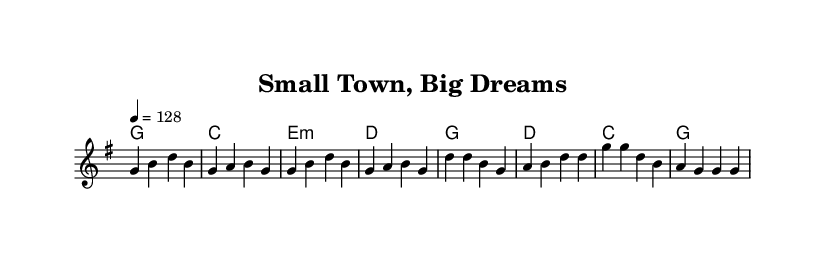What is the key signature of this music? The key signature is G major, indicated by one sharp (F#) which is visible in the sheet music’s key signature at the beginning.
Answer: G major What is the time signature of this music? The time signature is 4/4, which is shown at the beginning of the sheet music, indicating four beats per measure.
Answer: 4/4 What is the tempo marking for this piece? The tempo marking is 128 beats per minute, described in the tempo indication which is noted in the global section of the score.
Answer: 128 How many measures are in the verse? The verse consists of four measures, which can be counted from the melodic line where each measure has distinct rhythms and rests.
Answer: 4 What type of chords are used in the harmony for the verse? The harmony for the verse includes major and minor chords, specifically G major, C major, E minor, and D major as noted in the chord progression.
Answer: Major and minor What is the main theme of the lyrics in the chorus? The main theme of the chorus emphasizes hard work and traditional values, which reflect pride in one's small town and aspirations for the future stated in the lyrics.
Answer: Hard work and pride How does the melody of the chorus compare to the verse? The melody of the chorus features a higher pitch at the start (D note) and has a more uplifting phrasing, contrasting with the more stable and grounded lines in the verse.
Answer: Uplifting and higher pitch 